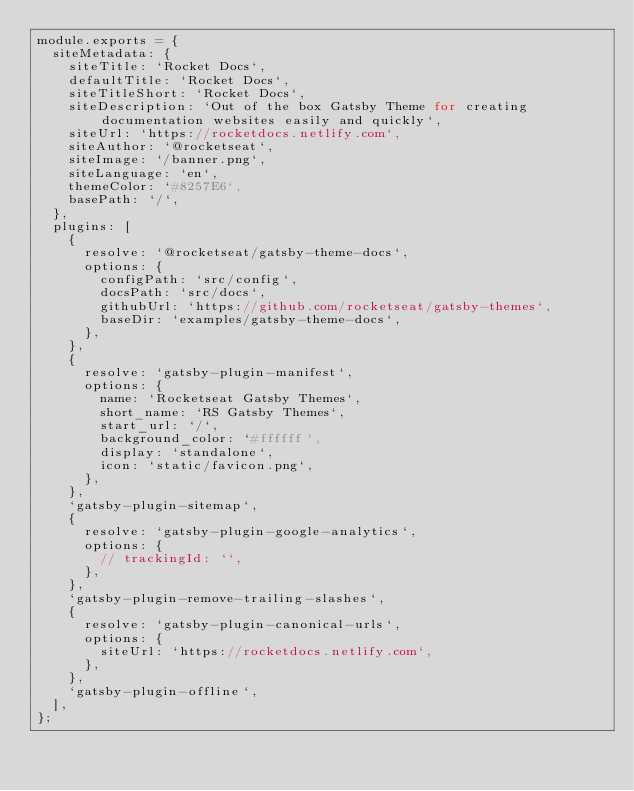<code> <loc_0><loc_0><loc_500><loc_500><_JavaScript_>module.exports = {
  siteMetadata: {
    siteTitle: `Rocket Docs`,
    defaultTitle: `Rocket Docs`,
    siteTitleShort: `Rocket Docs`,
    siteDescription: `Out of the box Gatsby Theme for creating documentation websites easily and quickly`,
    siteUrl: `https://rocketdocs.netlify.com`,
    siteAuthor: `@rocketseat`,
    siteImage: `/banner.png`,
    siteLanguage: `en`,
    themeColor: `#8257E6`,
    basePath: `/`,
  },
  plugins: [
    {
      resolve: `@rocketseat/gatsby-theme-docs`,
      options: {
        configPath: `src/config`,
        docsPath: `src/docs`,
        githubUrl: `https://github.com/rocketseat/gatsby-themes`,
        baseDir: `examples/gatsby-theme-docs`,
      },
    },
    {
      resolve: `gatsby-plugin-manifest`,
      options: {
        name: `Rocketseat Gatsby Themes`,
        short_name: `RS Gatsby Themes`,
        start_url: `/`,
        background_color: `#ffffff`,
        display: `standalone`,
        icon: `static/favicon.png`,
      },
    },
    `gatsby-plugin-sitemap`,
    {
      resolve: `gatsby-plugin-google-analytics`,
      options: {
        // trackingId: ``,
      },
    },
    `gatsby-plugin-remove-trailing-slashes`,
    {
      resolve: `gatsby-plugin-canonical-urls`,
      options: {
        siteUrl: `https://rocketdocs.netlify.com`,
      },
    },
    `gatsby-plugin-offline`,
  ],
};
</code> 